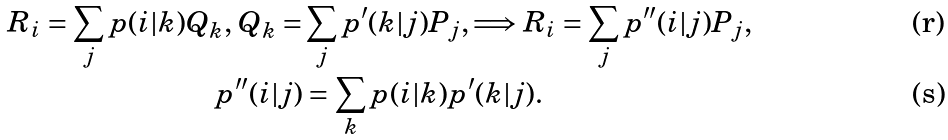<formula> <loc_0><loc_0><loc_500><loc_500>R _ { i } = \sum _ { j } p ( i | k ) Q _ { k } , \, Q _ { k } = & \sum _ { j } p ^ { \prime } ( k | j ) P _ { j } , \Longrightarrow R _ { i } = \sum _ { j } p ^ { \prime \prime } ( i | j ) P _ { j } , \\ p ^ { \prime \prime } ( i | j ) & = \sum _ { k } p ( i | k ) p ^ { \prime } ( k | j ) .</formula> 